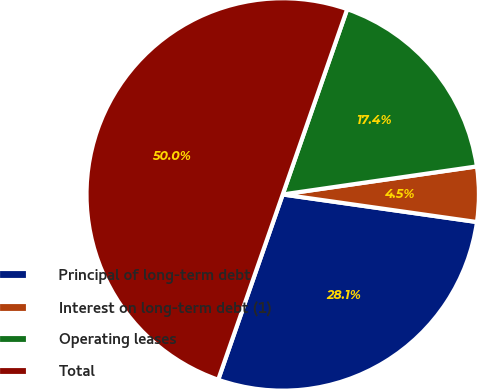<chart> <loc_0><loc_0><loc_500><loc_500><pie_chart><fcel>Principal of long-term debt<fcel>Interest on long-term debt (1)<fcel>Operating leases<fcel>Total<nl><fcel>28.09%<fcel>4.53%<fcel>17.39%<fcel>50.0%<nl></chart> 